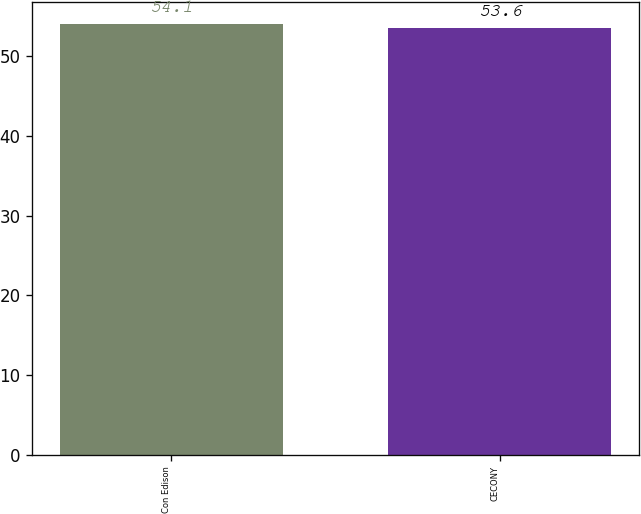Convert chart. <chart><loc_0><loc_0><loc_500><loc_500><bar_chart><fcel>Con Edison<fcel>CECONY<nl><fcel>54.1<fcel>53.6<nl></chart> 